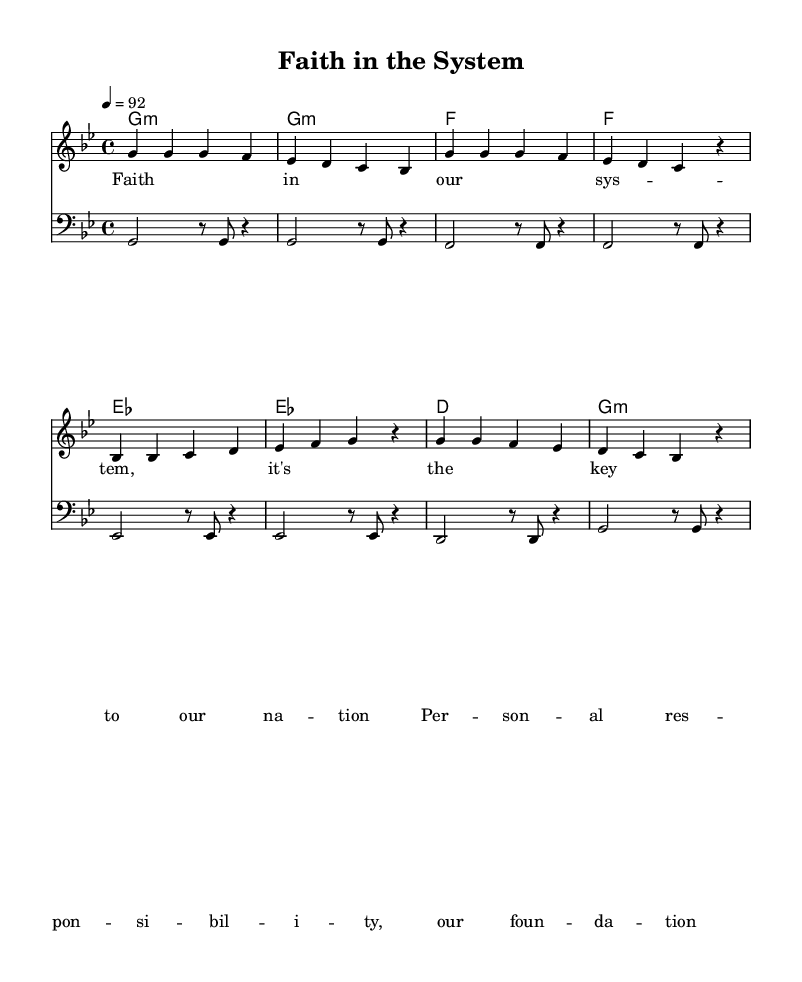What is the key signature of this music? The key is G minor, which has two flats in its key signature (B flat and E flat).
Answer: G minor What is the time signature of this music? The time signature is indicated at the beginning of the score, which is 4/4, meaning there are four beats per measure.
Answer: 4/4 What is the tempo marking for this piece? The tempo marking shows that the piece is to be played at a speed of 92 beats per minute, as indicated in the global section.
Answer: 92 How many measures are there in the melody? By counting the distinct segments in the melody section, there are 8 measures, as each group of notes separated by vertical lines represents one measure.
Answer: 8 What is the first lyric of the piece? The lyrics begin with the phrase "Faith in our system," as shown in the verse section directly below the melody.
Answer: Faith in our system Which chord is played on the first measure? The chord is G minor, as indicated in the chord names section at the beginning of the piece corresponding to the first measure.
Answer: G minor What is a prominent theme in the lyrics? The lyrics emphasize the importance of faith and personal responsibility, which are central themes in the song, as expressed throughout the lines.
Answer: Faith and responsibility 